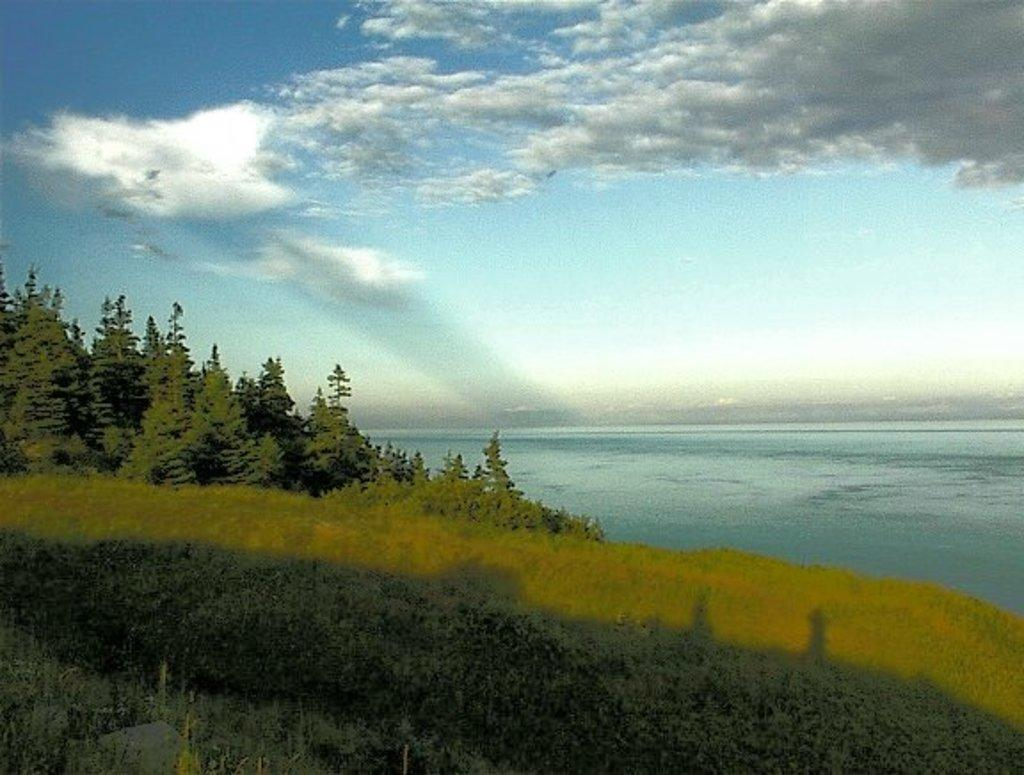What type of image is being described? The image is an animated picture. What can be seen in the foreground of the image? There are trees, plants, and grass in the foreground of the image. What is located in the center of the image? There is a water body in the center of the image. How would you describe the sky in the image? The sky is cloudy. Can you tell me what type of drink is being offered in the shade of the trees? There is no drink or shade of trees mentioned in the image; it only features an animated scene with trees, plants, grass, a water body, and a cloudy sky. 